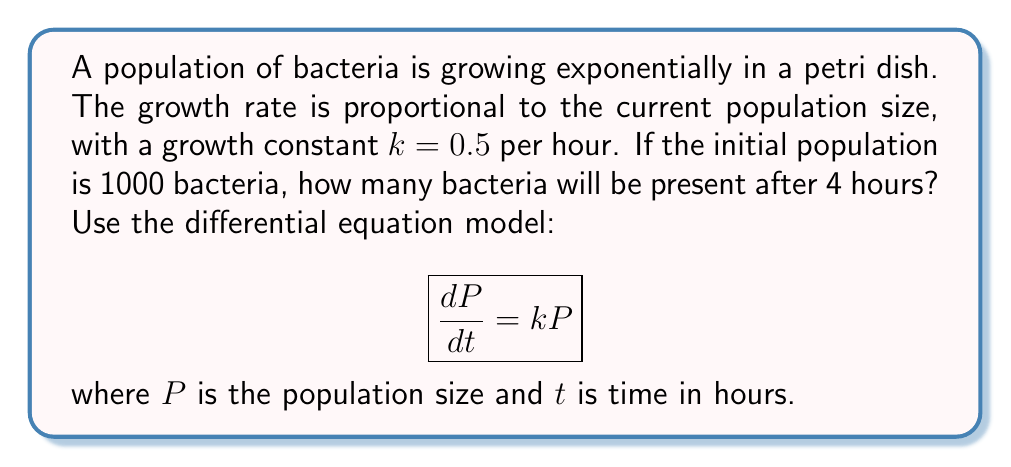Give your solution to this math problem. 1) The given differential equation is:
   $$\frac{dP}{dt} = kP$$

2) We know that $k = 0.5$ per hour and the initial population $P_0 = 1000$.

3) The solution to this differential equation is:
   $$P(t) = P_0e^{kt}$$

4) Substituting the known values:
   $$P(t) = 1000e^{0.5t}$$

5) We want to find $P(4)$, so let's substitute $t = 4$:
   $$P(4) = 1000e^{0.5(4)}$$

6) Simplify:
   $$P(4) = 1000e^2$$

7) Calculate:
   $$P(4) = 1000 * (e^2) \approx 7389$$

Therefore, after 4 hours, there will be approximately 7389 bacteria.
Answer: 7389 bacteria 